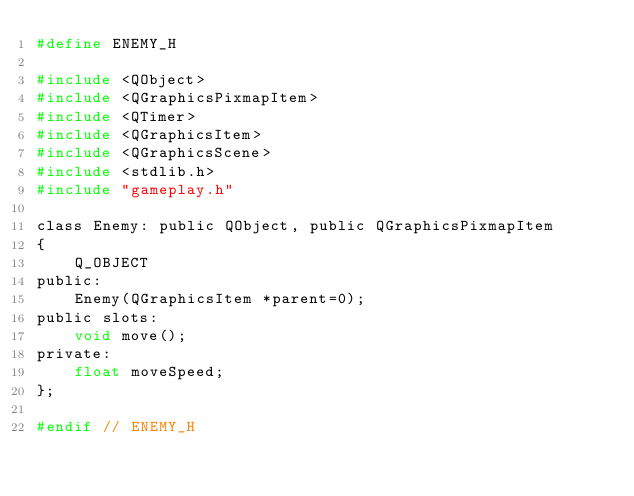<code> <loc_0><loc_0><loc_500><loc_500><_C_>#define ENEMY_H

#include <QObject>
#include <QGraphicsPixmapItem>
#include <QTimer>
#include <QGraphicsItem>
#include <QGraphicsScene>
#include <stdlib.h>
#include "gameplay.h"

class Enemy: public QObject, public QGraphicsPixmapItem
{
    Q_OBJECT
public:
    Enemy(QGraphicsItem *parent=0);
public slots:
    void move();
private:
    float moveSpeed;
};

#endif // ENEMY_H
</code> 